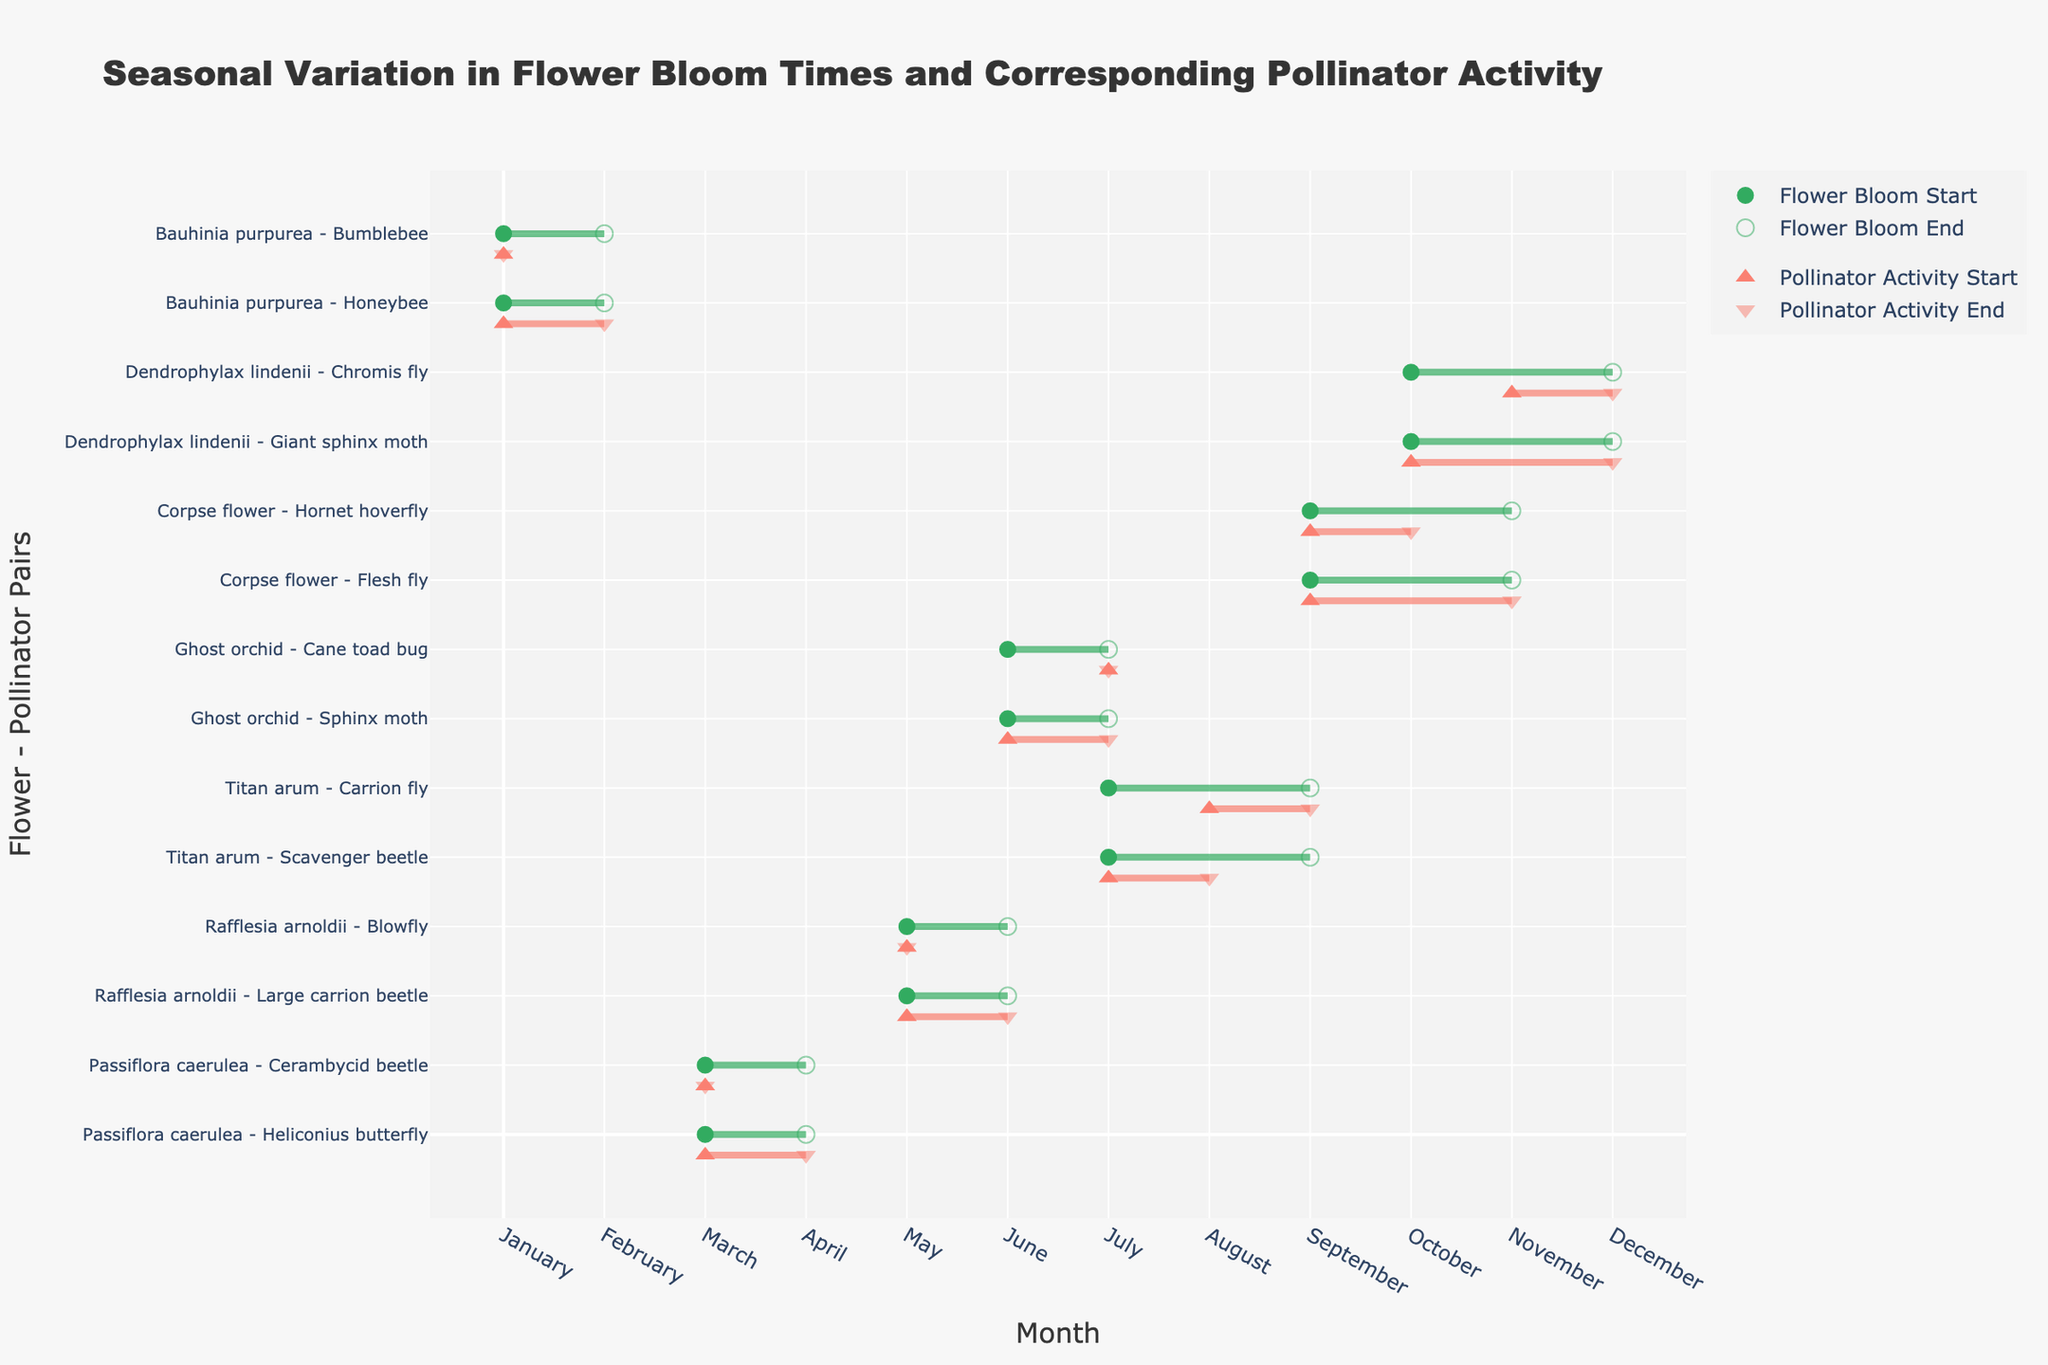What is the title of the figure? The title is usually displayed at the top of the chart. This one shows the intent of the plot, mentioning the seasonal variation in bloom times of flowers and their activities by pollinators.
Answer: Seasonal Variation in Flower Bloom Times and Corresponding Pollinator Activity Which flower has the longest bloom period? To find the longest bloom period, we need to look across the X-axis to see which flower spans the most months. 'Corpse flower' blooms from July to September, a period of three months.
Answer: Corpse flower During which months does the 'Titan arum' bloom? By looking at the respective 'Titan arum' row in the plot, we identify the bloom duration indicated by green markers and lines. The months are clearly labeled along the X-axis.
Answer: May and June Which pollinator is active for the 'Ghost orchid' in June? We need to look at the row corresponding to 'Ghost orchid' and identify the pollinator active in June, which is marked by the red line and markers.
Answer: Sphinx moth Are there any flowers and pollinators that start and end their activity in the same month? Identifying periods where both starting and ending points overlap within the same month. For example, 'Carrion fly' with 'Titan arum' both exhibit activity within May only.
Answer: Yes Which pollinator has the shortest activity period with 'Rafflesia arnoldii'? We look for the pollinator line associated with 'Rafflesia arnoldii' that spans a shorter period, i.e., from March to March only, which is 'Blowfly'.
Answer: Blowfly In what months do both 'Honeybee' and 'Bumblebee' pollinate 'Bauhinia purpurea'? Check the 'Bauhinia purpurea' section, noticing 'Honeybee' is active from October to December, and 'Bumblebee' from November to December. The common month is November and December.
Answer: November and December How many flowers bloom starting from May to June? Count the number of rows starting their bloom period in May and June by observing the lines starting at those months. Only 'Titan arum' matches this criterion.
Answer: 1 What's the average number of pollinators for flowers blooming from June to July? Identify flowers blooming in June or July and count their respective pollinators. 'Ghost orchid' has two pollinators, so the average is the total pollinators (2) divided by 1.
Answer: 2 